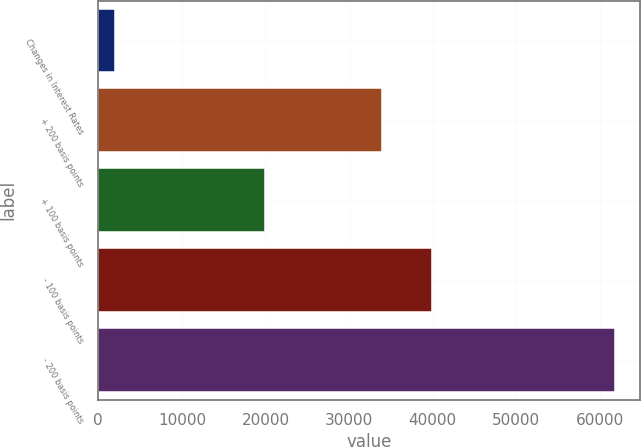Convert chart. <chart><loc_0><loc_0><loc_500><loc_500><bar_chart><fcel>Changes in Interest Rates<fcel>+ 200 basis points<fcel>+ 100 basis points<fcel>- 100 basis points<fcel>- 200 basis points<nl><fcel>2009<fcel>33974<fcel>19989<fcel>39946<fcel>61729<nl></chart> 